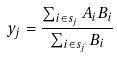<formula> <loc_0><loc_0><loc_500><loc_500>y _ { j } = \frac { \sum _ { i \in s _ { j } } A _ { i } B _ { i } } { \sum _ { i \in s _ { j } } B _ { i } }</formula> 